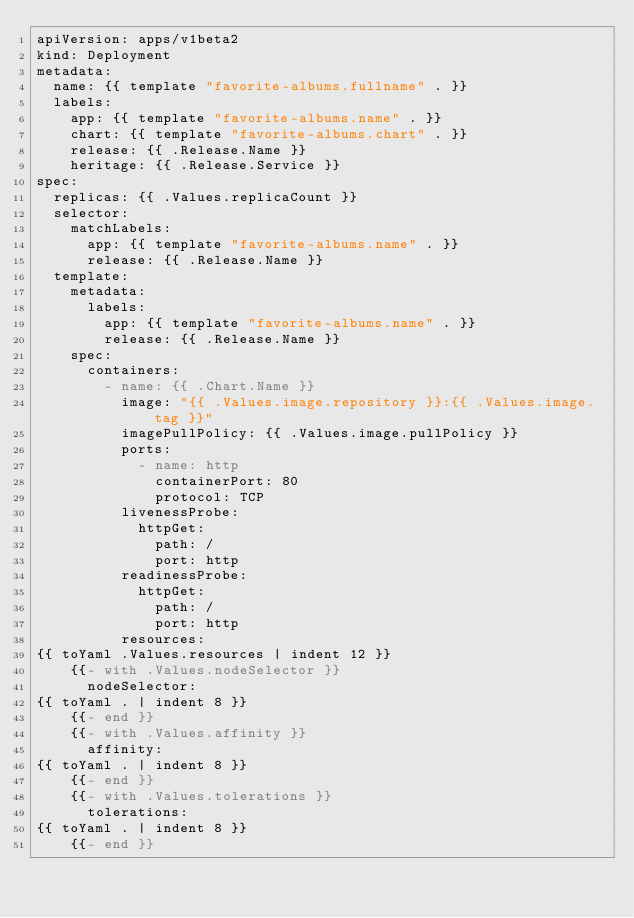<code> <loc_0><loc_0><loc_500><loc_500><_YAML_>apiVersion: apps/v1beta2
kind: Deployment
metadata:
  name: {{ template "favorite-albums.fullname" . }}
  labels:
    app: {{ template "favorite-albums.name" . }}
    chart: {{ template "favorite-albums.chart" . }}
    release: {{ .Release.Name }}
    heritage: {{ .Release.Service }}
spec:
  replicas: {{ .Values.replicaCount }}
  selector:
    matchLabels:
      app: {{ template "favorite-albums.name" . }}
      release: {{ .Release.Name }}
  template:
    metadata:
      labels:
        app: {{ template "favorite-albums.name" . }}
        release: {{ .Release.Name }}
    spec:
      containers:
        - name: {{ .Chart.Name }}
          image: "{{ .Values.image.repository }}:{{ .Values.image.tag }}"
          imagePullPolicy: {{ .Values.image.pullPolicy }}
          ports:
            - name: http
              containerPort: 80
              protocol: TCP
          livenessProbe:
            httpGet:
              path: /
              port: http
          readinessProbe:
            httpGet:
              path: /
              port: http
          resources:
{{ toYaml .Values.resources | indent 12 }}
    {{- with .Values.nodeSelector }}
      nodeSelector:
{{ toYaml . | indent 8 }}
    {{- end }}
    {{- with .Values.affinity }}
      affinity:
{{ toYaml . | indent 8 }}
    {{- end }}
    {{- with .Values.tolerations }}
      tolerations:
{{ toYaml . | indent 8 }}
    {{- end }}
</code> 